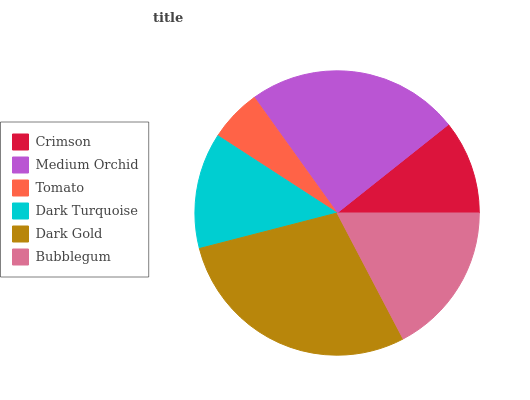Is Tomato the minimum?
Answer yes or no. Yes. Is Dark Gold the maximum?
Answer yes or no. Yes. Is Medium Orchid the minimum?
Answer yes or no. No. Is Medium Orchid the maximum?
Answer yes or no. No. Is Medium Orchid greater than Crimson?
Answer yes or no. Yes. Is Crimson less than Medium Orchid?
Answer yes or no. Yes. Is Crimson greater than Medium Orchid?
Answer yes or no. No. Is Medium Orchid less than Crimson?
Answer yes or no. No. Is Bubblegum the high median?
Answer yes or no. Yes. Is Dark Turquoise the low median?
Answer yes or no. Yes. Is Crimson the high median?
Answer yes or no. No. Is Medium Orchid the low median?
Answer yes or no. No. 